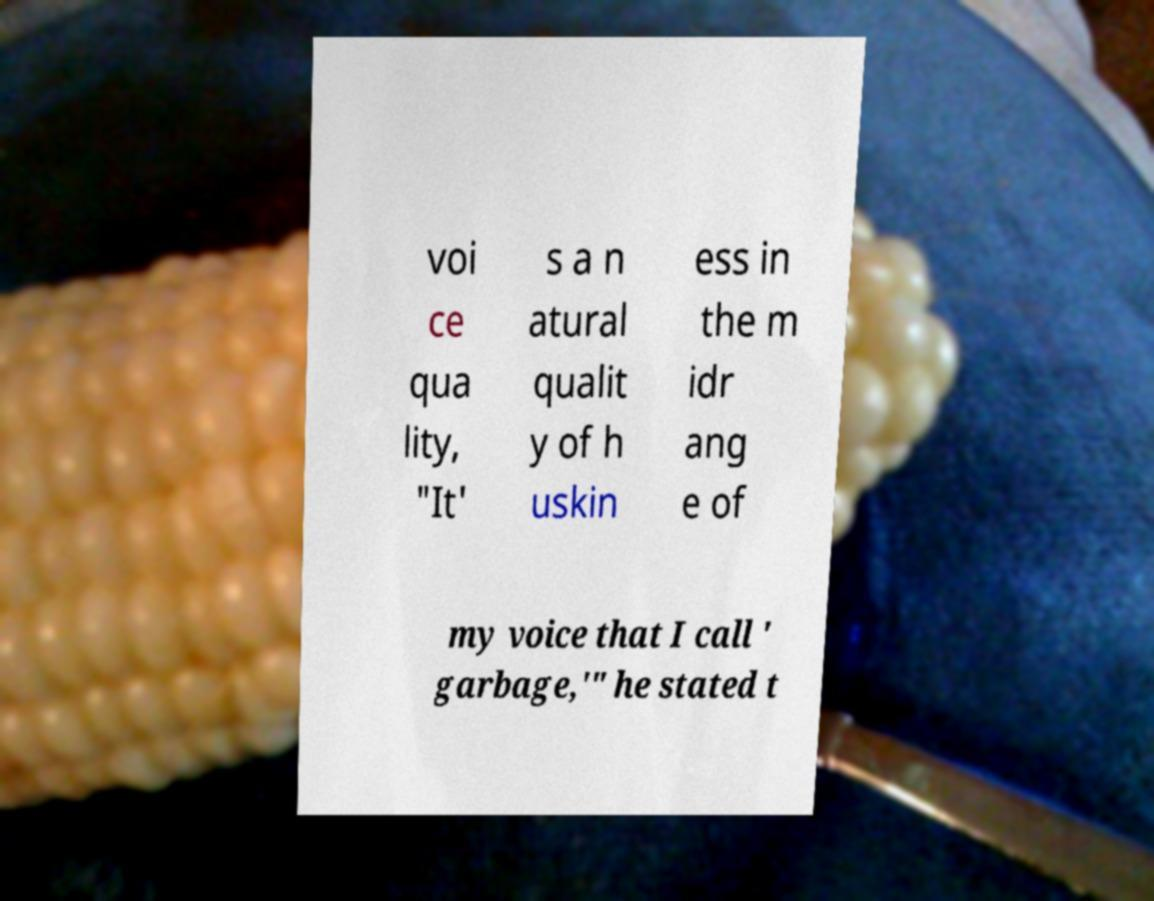Can you accurately transcribe the text from the provided image for me? voi ce qua lity, "It' s a n atural qualit y of h uskin ess in the m idr ang e of my voice that I call ' garbage,'" he stated t 